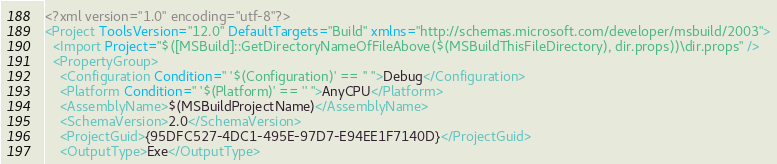Convert code to text. <code><loc_0><loc_0><loc_500><loc_500><_XML_><?xml version="1.0" encoding="utf-8"?>
<Project ToolsVersion="12.0" DefaultTargets="Build" xmlns="http://schemas.microsoft.com/developer/msbuild/2003">
  <Import Project="$([MSBuild]::GetDirectoryNameOfFileAbove($(MSBuildThisFileDirectory), dir.props))\dir.props" />
  <PropertyGroup>
    <Configuration Condition=" '$(Configuration)' == '' ">Debug</Configuration>
    <Platform Condition=" '$(Platform)' == '' ">AnyCPU</Platform>
    <AssemblyName>$(MSBuildProjectName)</AssemblyName>
    <SchemaVersion>2.0</SchemaVersion>
    <ProjectGuid>{95DFC527-4DC1-495E-97D7-E94EE1F7140D}</ProjectGuid>
    <OutputType>Exe</OutputType></code> 